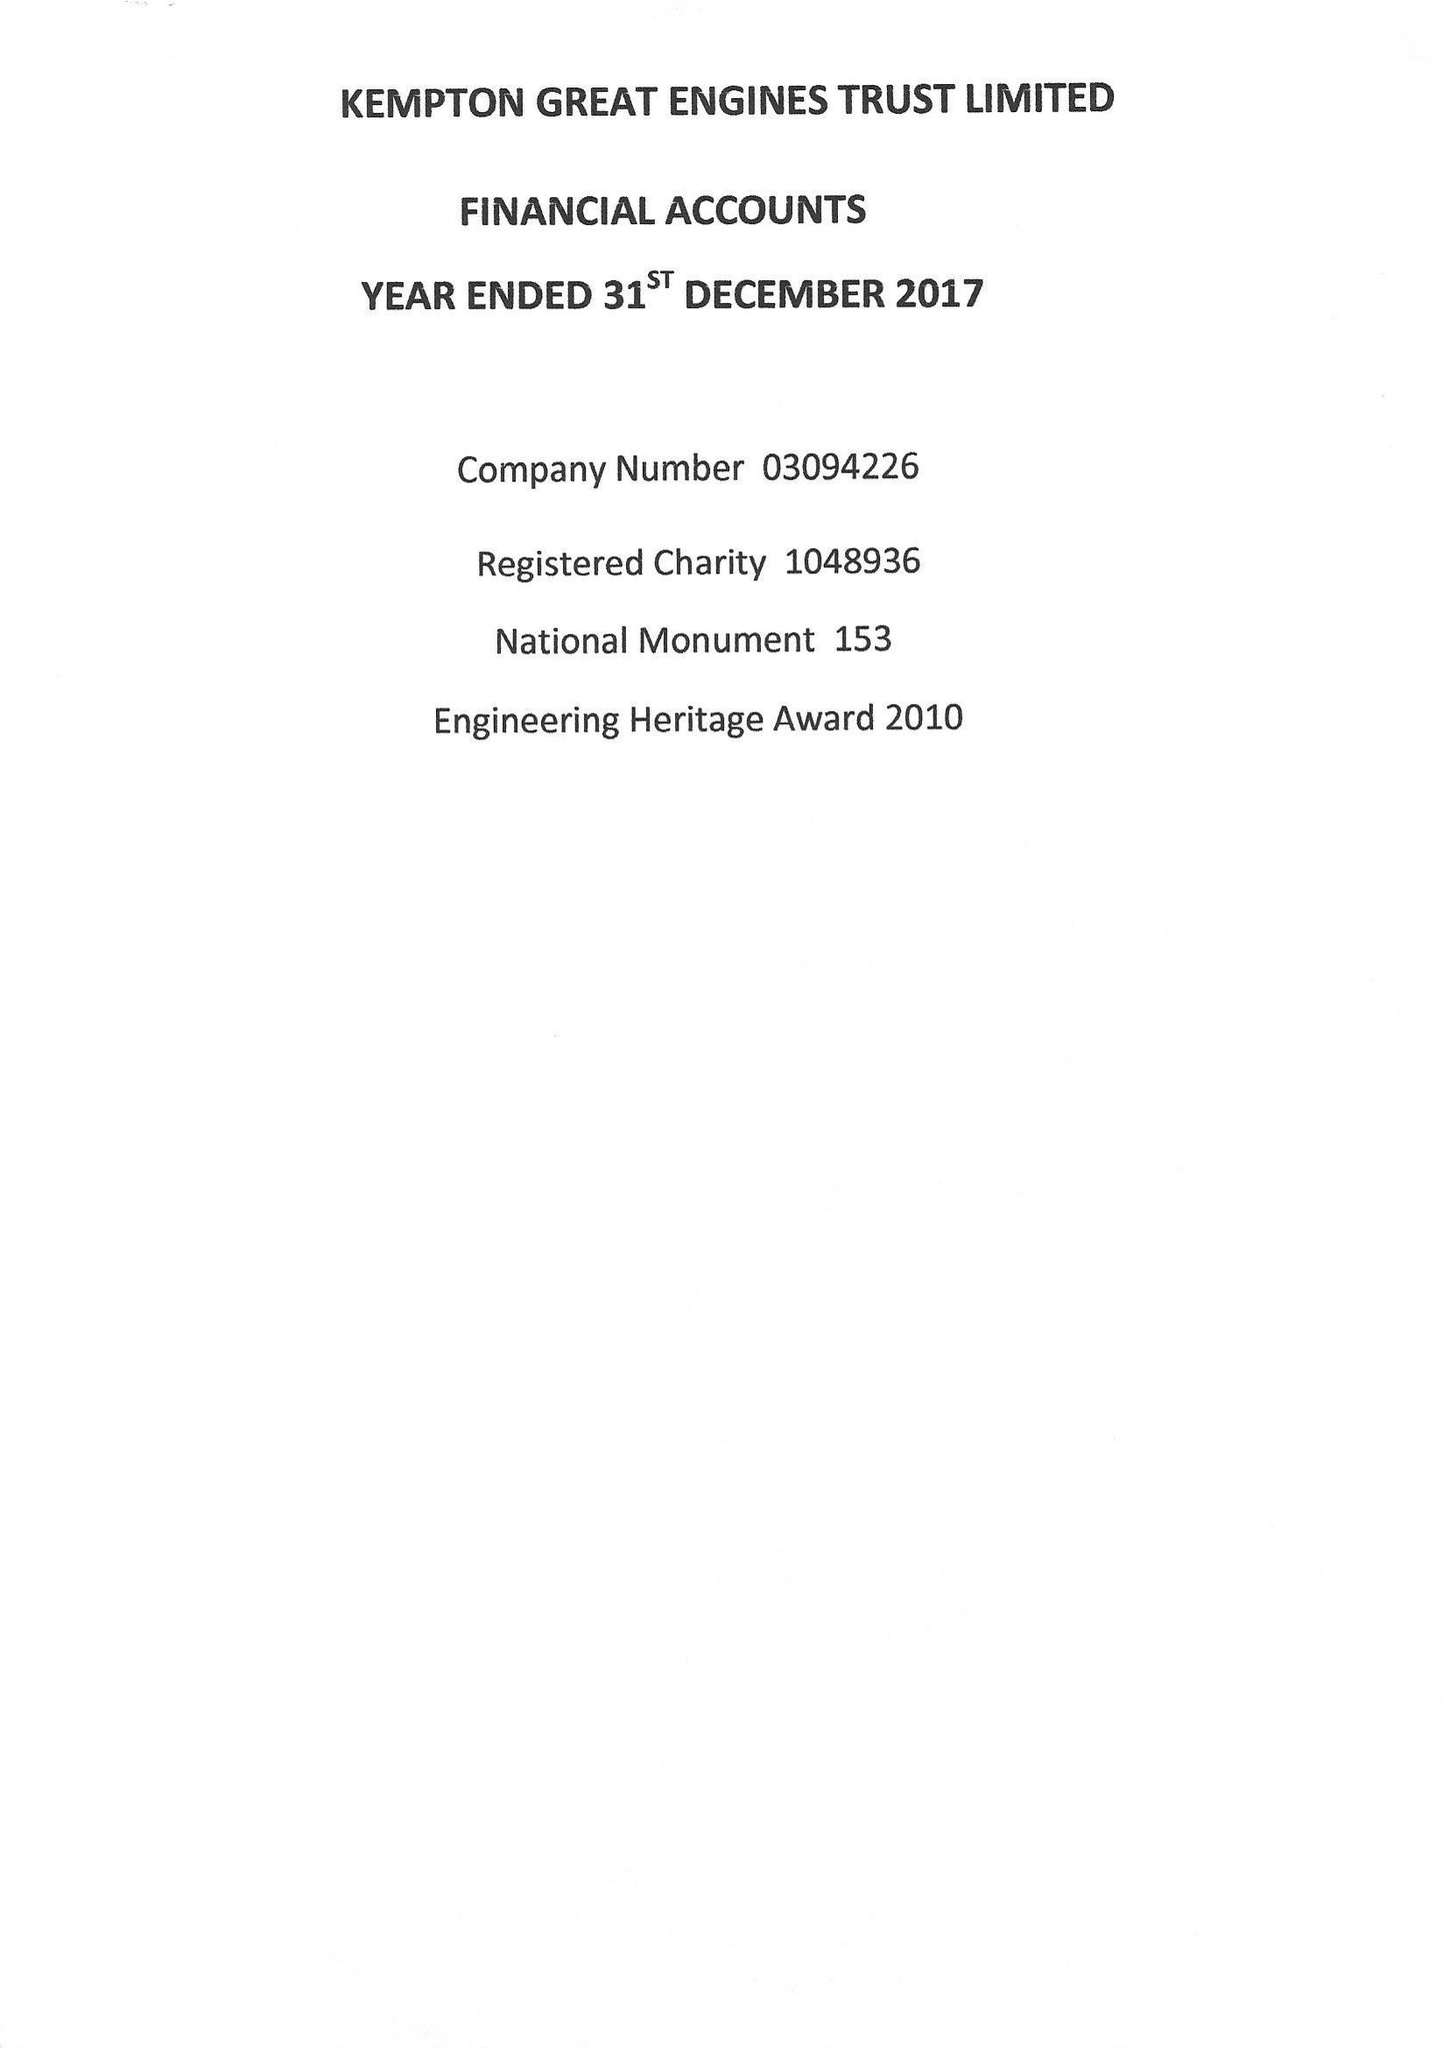What is the value for the address__postcode?
Answer the question using a single word or phrase. TW13 6XH 